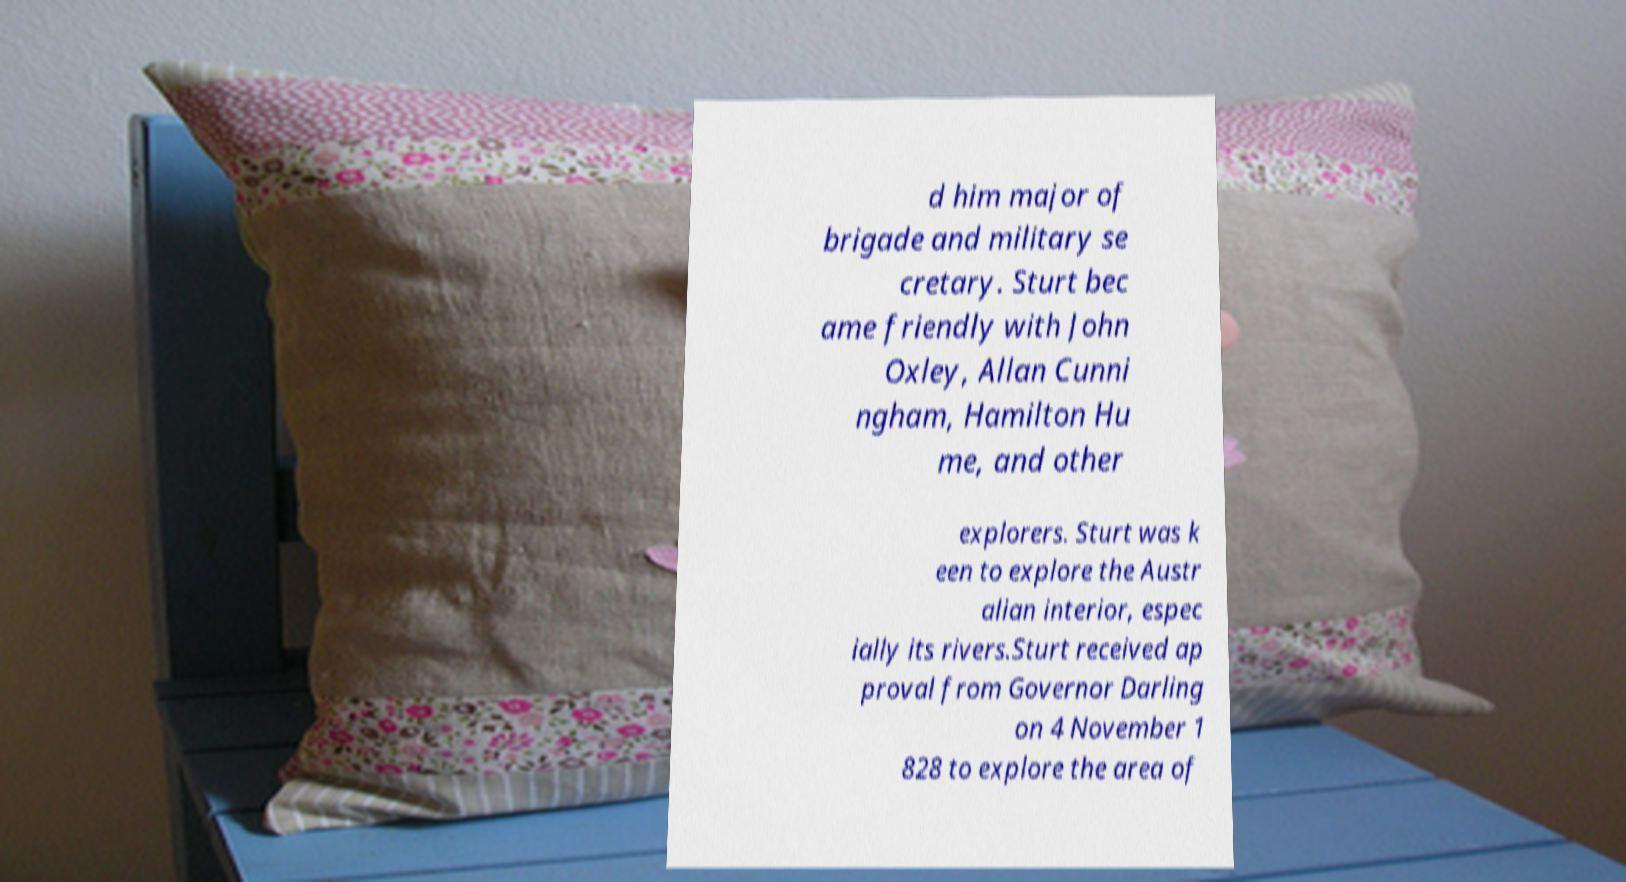Please read and relay the text visible in this image. What does it say? d him major of brigade and military se cretary. Sturt bec ame friendly with John Oxley, Allan Cunni ngham, Hamilton Hu me, and other explorers. Sturt was k een to explore the Austr alian interior, espec ially its rivers.Sturt received ap proval from Governor Darling on 4 November 1 828 to explore the area of 